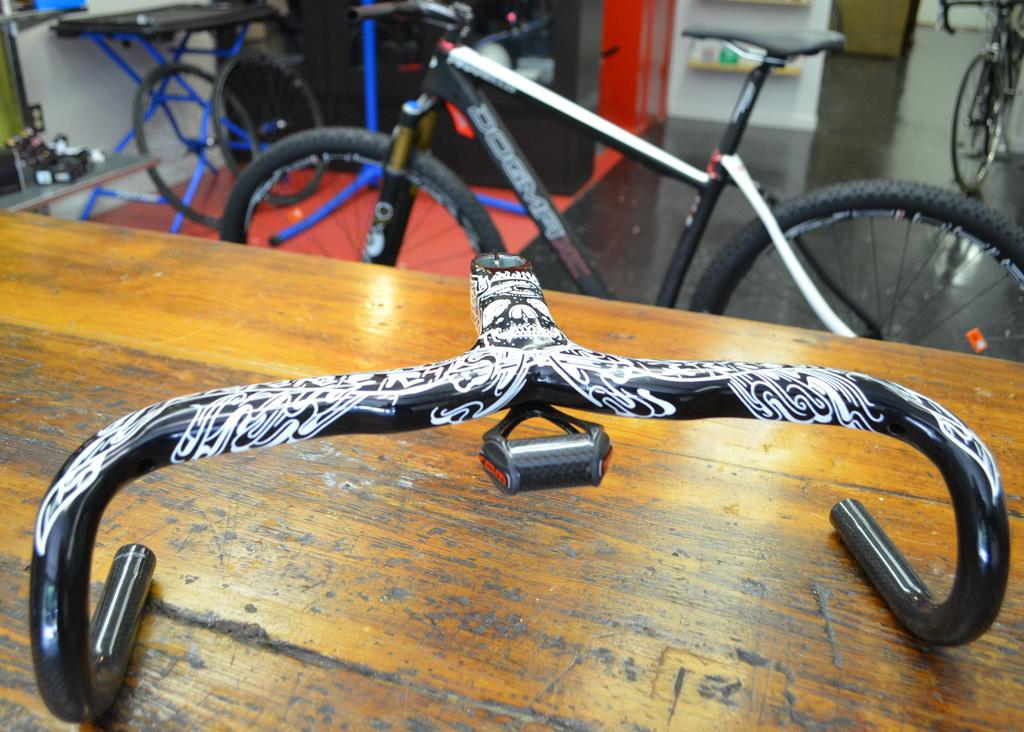What is the main object in the foreground of the image? There is a wooden plank in the image. What part of a bicycle can be seen in the image? A bicycle handle is visible in the image. What can be seen in the background of the image? There are bicycles, a table, and a wall in the background of the image. How many bushes are present in the image? There are no bushes present in the image. What type of lock is used to secure the bicycles in the image? There is no lock visible in the image, as it only shows a wooden plank, a bicycle handle, and the background with bicycles, a table, and a wall. 